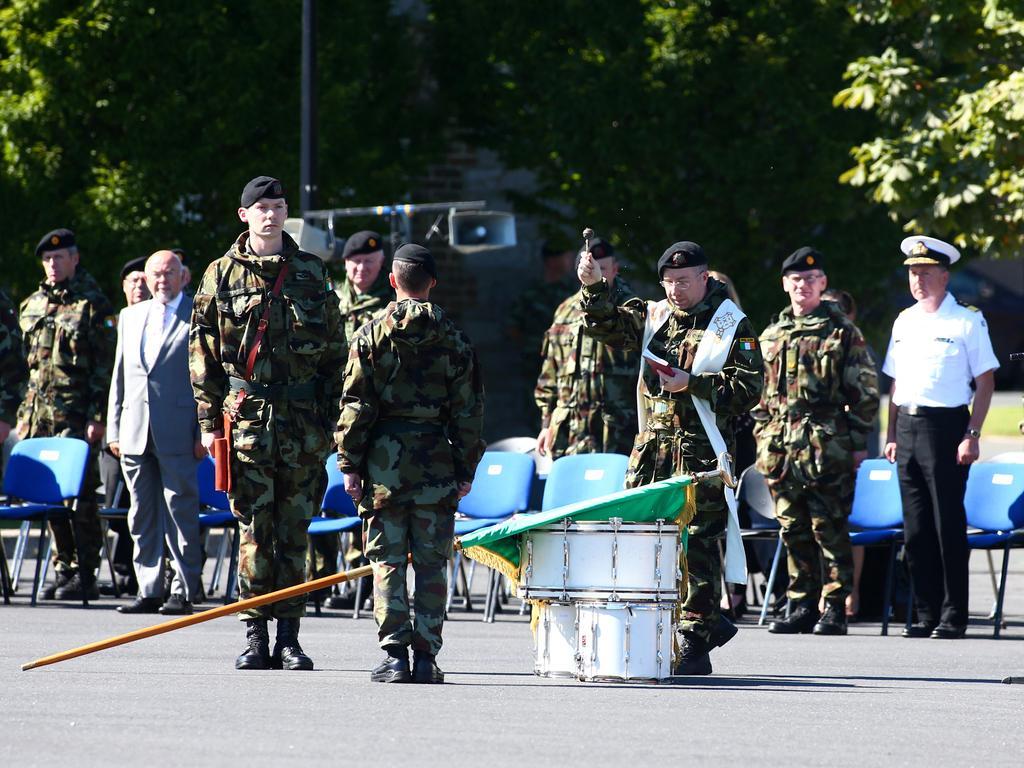How would you summarize this image in a sentence or two? In this image I can see the group of people standing on the road. I can see the drums and flag in-front of these people. I can see these people with uniforms and one person wearing the blazer. In the background I can see the pope, sound box and many trees. 